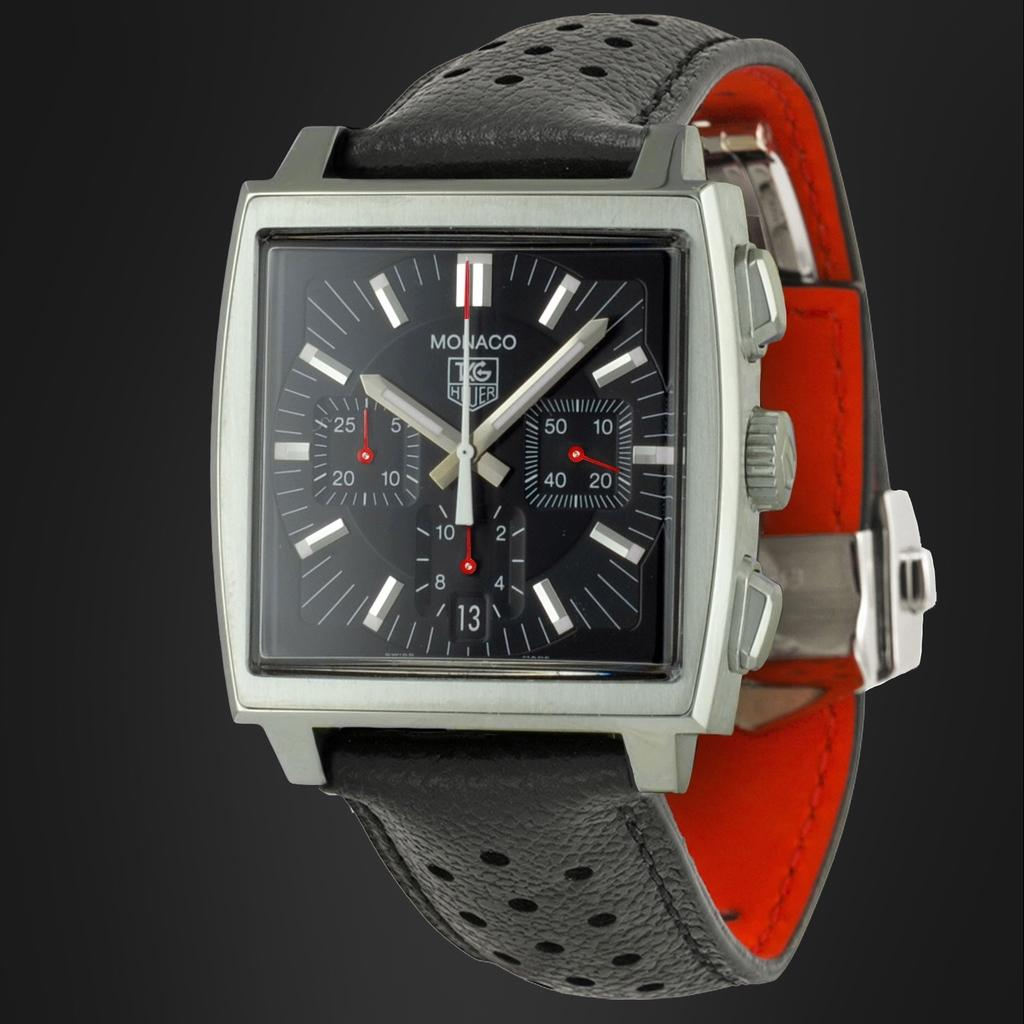<image>
Create a compact narrative representing the image presented. A square-faced Monaco watch in black and red. 